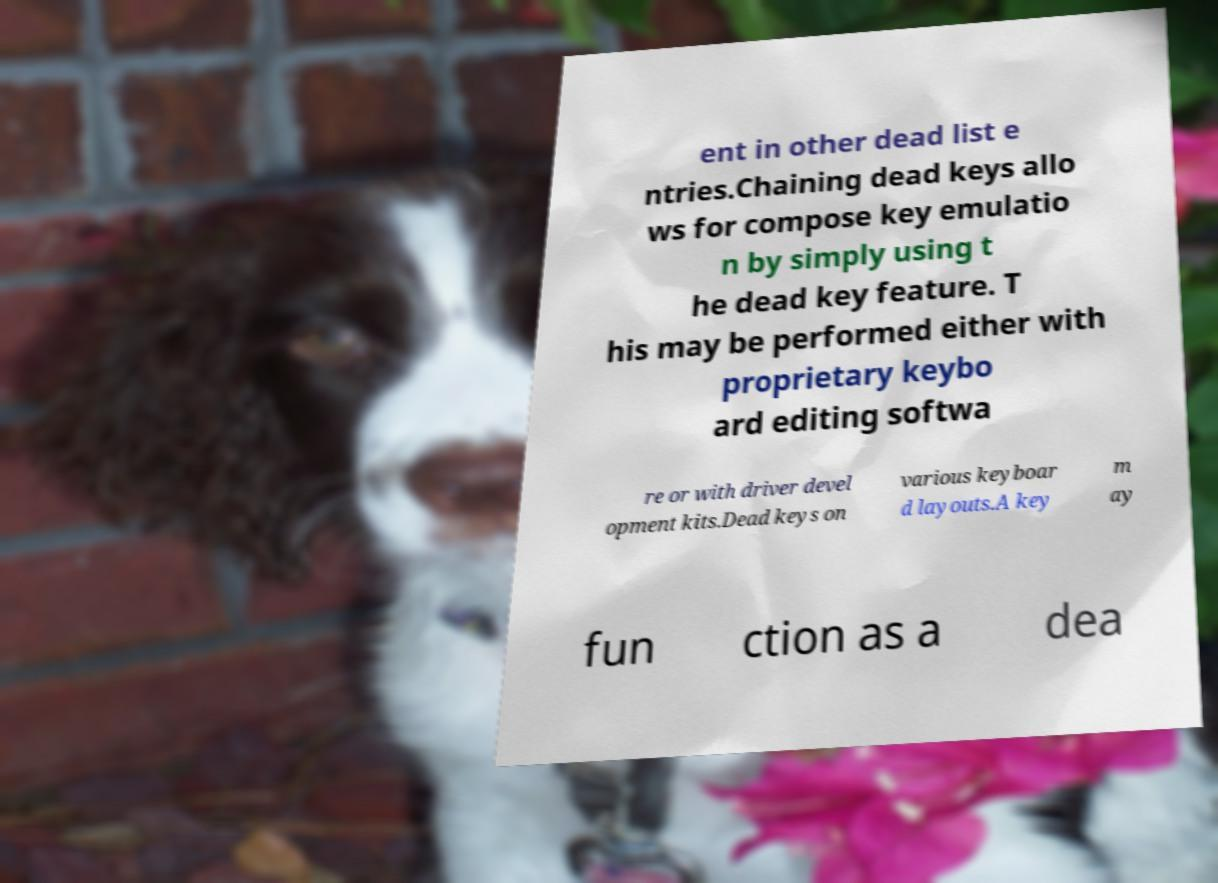Please read and relay the text visible in this image. What does it say? ent in other dead list e ntries.Chaining dead keys allo ws for compose key emulatio n by simply using t he dead key feature. T his may be performed either with proprietary keybo ard editing softwa re or with driver devel opment kits.Dead keys on various keyboar d layouts.A key m ay fun ction as a dea 